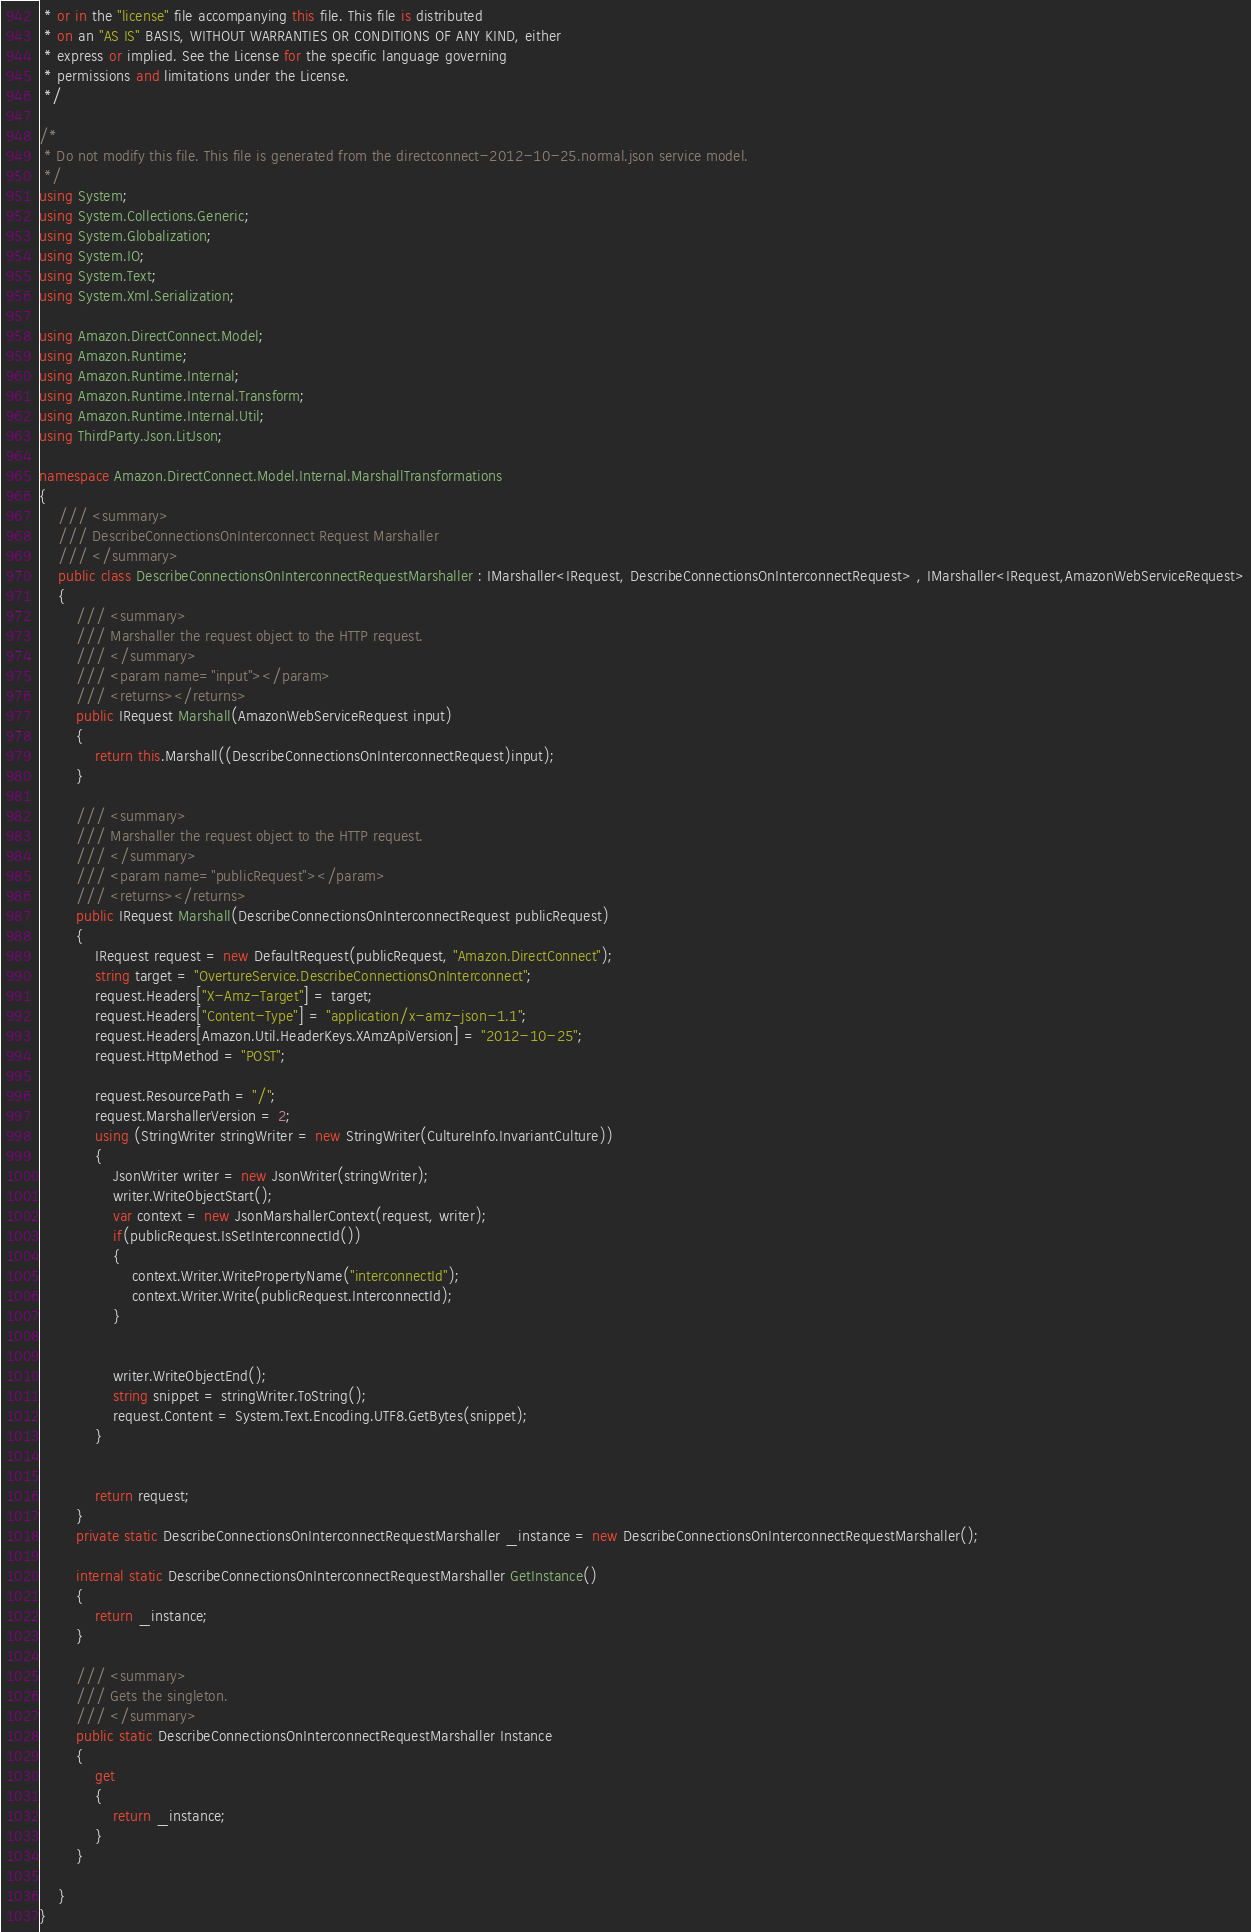Convert code to text. <code><loc_0><loc_0><loc_500><loc_500><_C#_> * or in the "license" file accompanying this file. This file is distributed
 * on an "AS IS" BASIS, WITHOUT WARRANTIES OR CONDITIONS OF ANY KIND, either
 * express or implied. See the License for the specific language governing
 * permissions and limitations under the License.
 */

/*
 * Do not modify this file. This file is generated from the directconnect-2012-10-25.normal.json service model.
 */
using System;
using System.Collections.Generic;
using System.Globalization;
using System.IO;
using System.Text;
using System.Xml.Serialization;

using Amazon.DirectConnect.Model;
using Amazon.Runtime;
using Amazon.Runtime.Internal;
using Amazon.Runtime.Internal.Transform;
using Amazon.Runtime.Internal.Util;
using ThirdParty.Json.LitJson;

namespace Amazon.DirectConnect.Model.Internal.MarshallTransformations
{
    /// <summary>
    /// DescribeConnectionsOnInterconnect Request Marshaller
    /// </summary>       
    public class DescribeConnectionsOnInterconnectRequestMarshaller : IMarshaller<IRequest, DescribeConnectionsOnInterconnectRequest> , IMarshaller<IRequest,AmazonWebServiceRequest>
    {
        /// <summary>
        /// Marshaller the request object to the HTTP request.
        /// </summary>  
        /// <param name="input"></param>
        /// <returns></returns>
        public IRequest Marshall(AmazonWebServiceRequest input)
        {
            return this.Marshall((DescribeConnectionsOnInterconnectRequest)input);
        }

        /// <summary>
        /// Marshaller the request object to the HTTP request.
        /// </summary>  
        /// <param name="publicRequest"></param>
        /// <returns></returns>
        public IRequest Marshall(DescribeConnectionsOnInterconnectRequest publicRequest)
        {
            IRequest request = new DefaultRequest(publicRequest, "Amazon.DirectConnect");
            string target = "OvertureService.DescribeConnectionsOnInterconnect";
            request.Headers["X-Amz-Target"] = target;
            request.Headers["Content-Type"] = "application/x-amz-json-1.1";
            request.Headers[Amazon.Util.HeaderKeys.XAmzApiVersion] = "2012-10-25";            
            request.HttpMethod = "POST";

            request.ResourcePath = "/";
            request.MarshallerVersion = 2;
            using (StringWriter stringWriter = new StringWriter(CultureInfo.InvariantCulture))
            {
                JsonWriter writer = new JsonWriter(stringWriter);
                writer.WriteObjectStart();
                var context = new JsonMarshallerContext(request, writer);
                if(publicRequest.IsSetInterconnectId())
                {
                    context.Writer.WritePropertyName("interconnectId");
                    context.Writer.Write(publicRequest.InterconnectId);
                }

        
                writer.WriteObjectEnd();
                string snippet = stringWriter.ToString();
                request.Content = System.Text.Encoding.UTF8.GetBytes(snippet);
            }


            return request;
        }
        private static DescribeConnectionsOnInterconnectRequestMarshaller _instance = new DescribeConnectionsOnInterconnectRequestMarshaller();        

        internal static DescribeConnectionsOnInterconnectRequestMarshaller GetInstance()
        {
            return _instance;
        }

        /// <summary>
        /// Gets the singleton.
        /// </summary>  
        public static DescribeConnectionsOnInterconnectRequestMarshaller Instance
        {
            get
            {
                return _instance;
            }
        }

    }
}</code> 